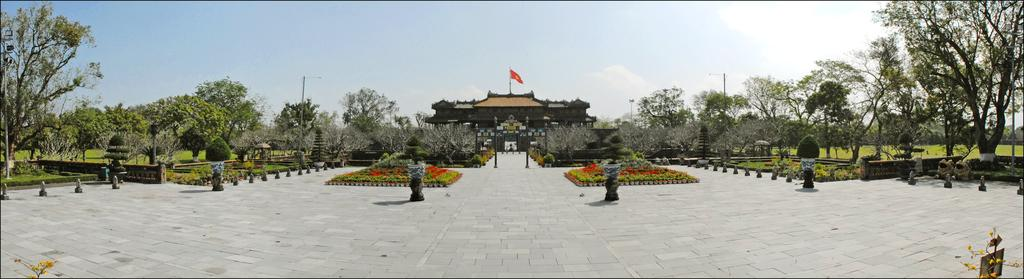What type of structure is visible in the image? There is a house in the image. What is attached to the house? The house has a flag. What type of vegetation can be seen in the image? There are trees, plants, and grass in the image. What type of containers are present in the image? There are flower pots in the image. What is visible at the bottom of the image? The bottom of the image contains a floor. What is visible at the top of the image? The top of the image contains the sky. What type of wound can be seen on the cat in the image? There is no cat present in the image, and therefore no wound can be observed. 